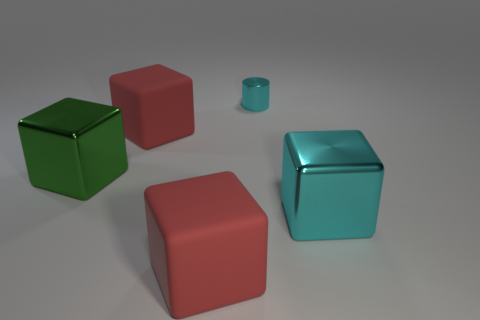What is the small cylinder made of? The small cylinder in the image appears to be made of a reflective metal, likely aluminum or stainless steel, given its polished surface and the way it interacts with light. 